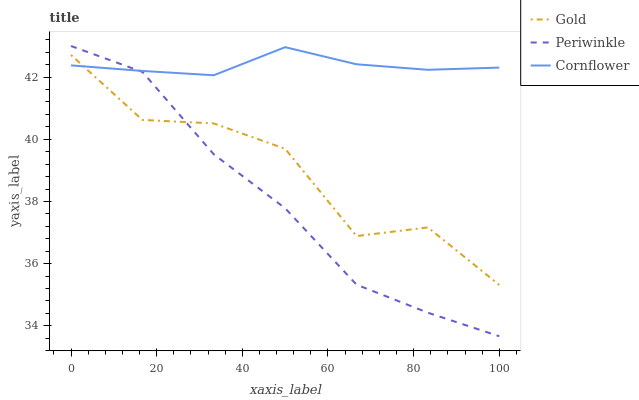Does Periwinkle have the minimum area under the curve?
Answer yes or no. Yes. Does Cornflower have the maximum area under the curve?
Answer yes or no. Yes. Does Gold have the minimum area under the curve?
Answer yes or no. No. Does Gold have the maximum area under the curve?
Answer yes or no. No. Is Cornflower the smoothest?
Answer yes or no. Yes. Is Gold the roughest?
Answer yes or no. Yes. Is Periwinkle the smoothest?
Answer yes or no. No. Is Periwinkle the roughest?
Answer yes or no. No. Does Periwinkle have the lowest value?
Answer yes or no. Yes. Does Gold have the lowest value?
Answer yes or no. No. Does Periwinkle have the highest value?
Answer yes or no. Yes. Does Gold have the highest value?
Answer yes or no. No. Does Gold intersect Cornflower?
Answer yes or no. Yes. Is Gold less than Cornflower?
Answer yes or no. No. Is Gold greater than Cornflower?
Answer yes or no. No. 